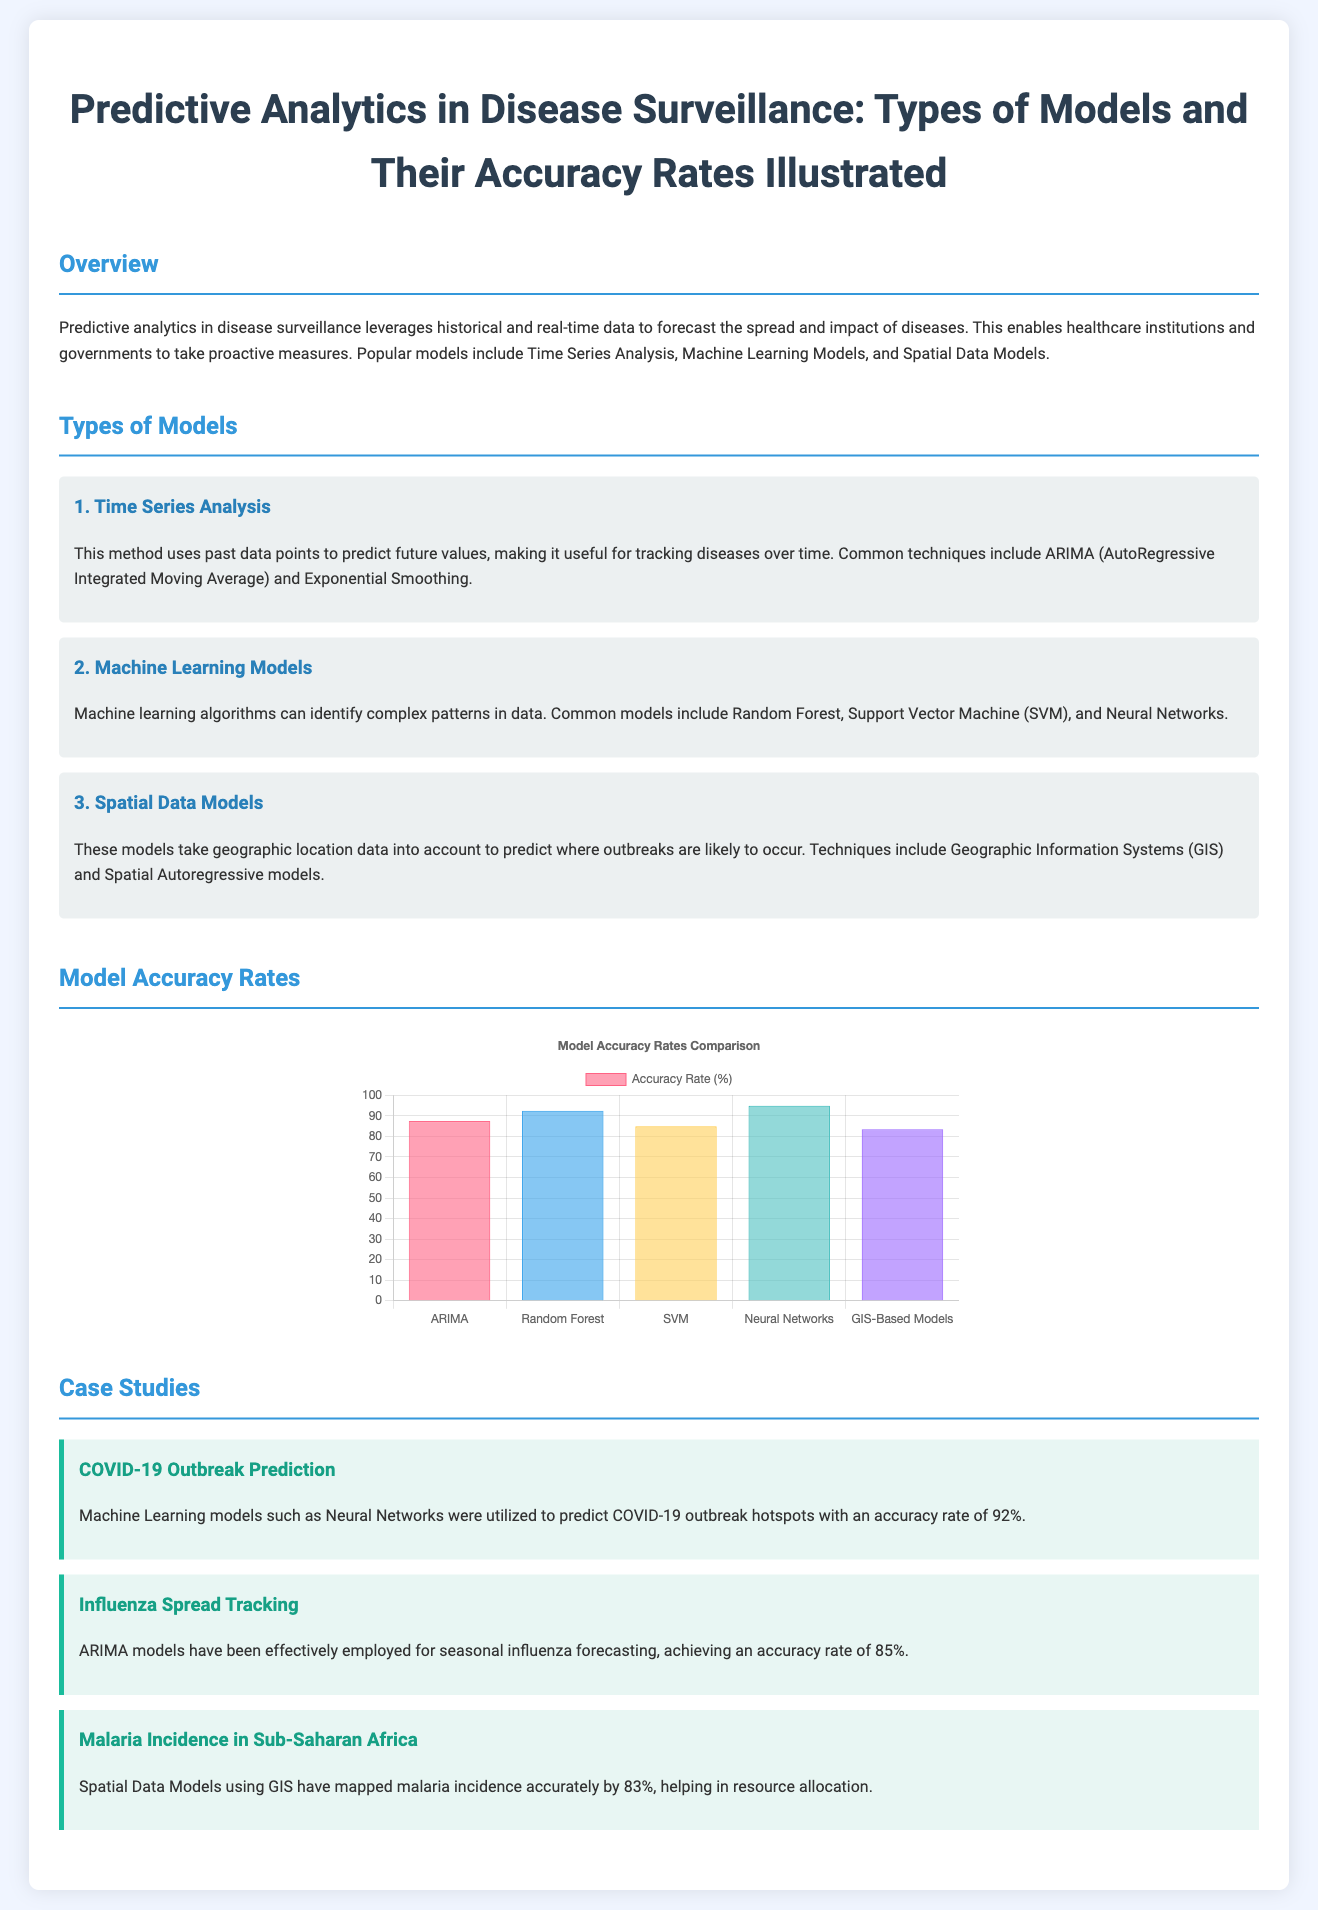what is the accuracy rate of Neural Networks in predicting COVID-19 hotspots? The accuracy rate for Neural Networks used in predicting COVID-19 outbreaks is stated in the case study section of the document.
Answer: 92% which model achieved the highest accuracy rate in the chart? In the chart displaying model accuracy rates, the model with the highest accuracy is specified.
Answer: Neural Networks what technique is commonly used in Time Series Analysis? The document lists ARIMA as a common technique used in Time Series Analysis under the Types of Models section.
Answer: ARIMA what percentage accuracy do GIS-Based Models achieve? The accuracy rate for GIS-Based Models is provided in the Model Accuracy Rates section of the document.
Answer: 83.5% what is the primary focus of predictive analytics in disease surveillance? The introductory section outlines the overall purpose of predictive analytics in disease surveillance.
Answer: Forecast the spread and impact of diseases which model is used for seasonal influenza forecasting? The document identifies ARIMA models as well-suited for seasonal influenza forecasting in the case study section.
Answer: ARIMA how many types of models are discussed in the document? The overview section indicates the number of model types covered in the document.
Answer: Three what is one application of Spatial Data Models mentioned? The description in the Types of Models section indicates the application of Spatial Data Models regarding outbreaks.
Answer: Geographic location data 